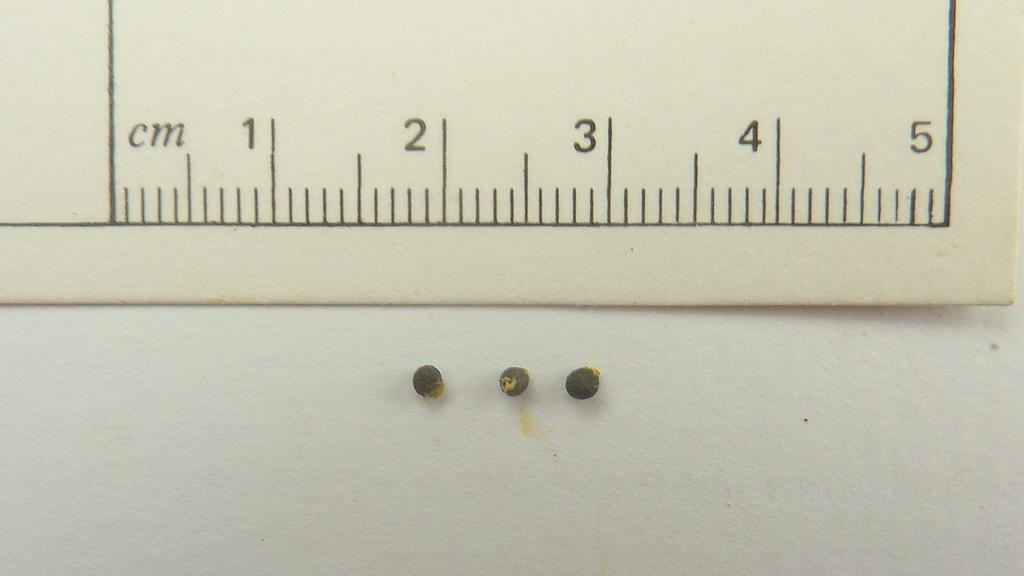<image>
Render a clear and concise summary of the photo. A white five cm ruler with black fon and in front three black beads around the numbers 2 and 3 of the scale of the ruller. 